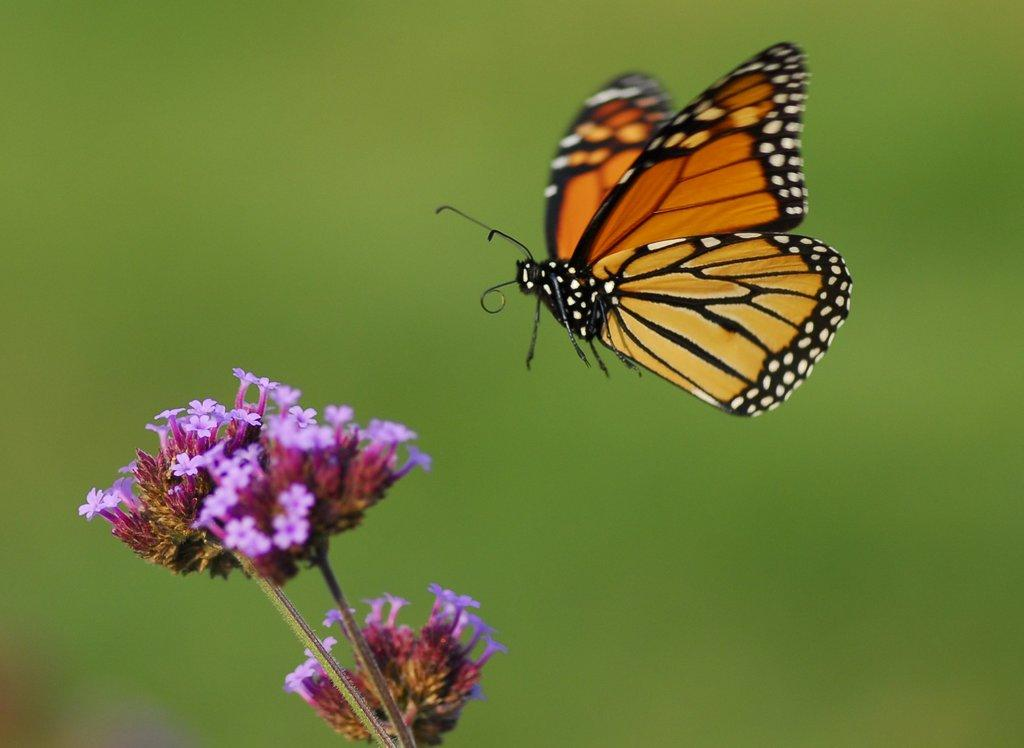What type of animal can be seen in the image? There is a butterfly in the image. What other living organism is present in the image? There is a plant in the image. What additional features can be observed on the plant? There are flowers in the image. How would you describe the background of the image? The background of the image is blurred. What type of egg can be seen in the image? There is no egg present in the image. Can you describe the camp setting in the image? There is no camp setting in the image; it features a butterfly, a plant, and flowers. 